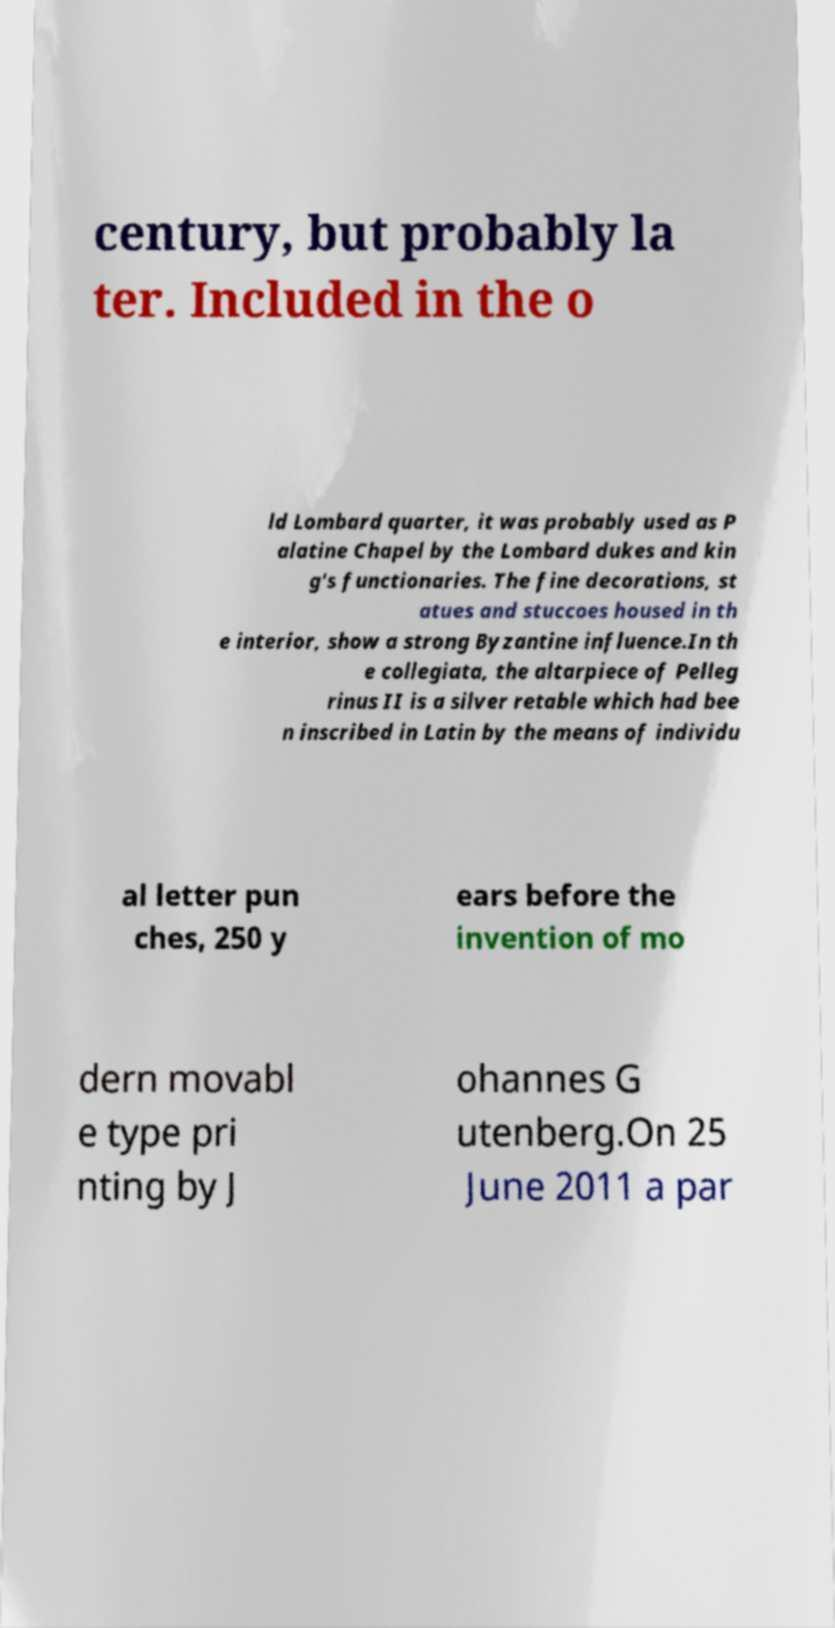There's text embedded in this image that I need extracted. Can you transcribe it verbatim? century, but probably la ter. Included in the o ld Lombard quarter, it was probably used as P alatine Chapel by the Lombard dukes and kin g's functionaries. The fine decorations, st atues and stuccoes housed in th e interior, show a strong Byzantine influence.In th e collegiata, the altarpiece of Pelleg rinus II is a silver retable which had bee n inscribed in Latin by the means of individu al letter pun ches, 250 y ears before the invention of mo dern movabl e type pri nting by J ohannes G utenberg.On 25 June 2011 a par 